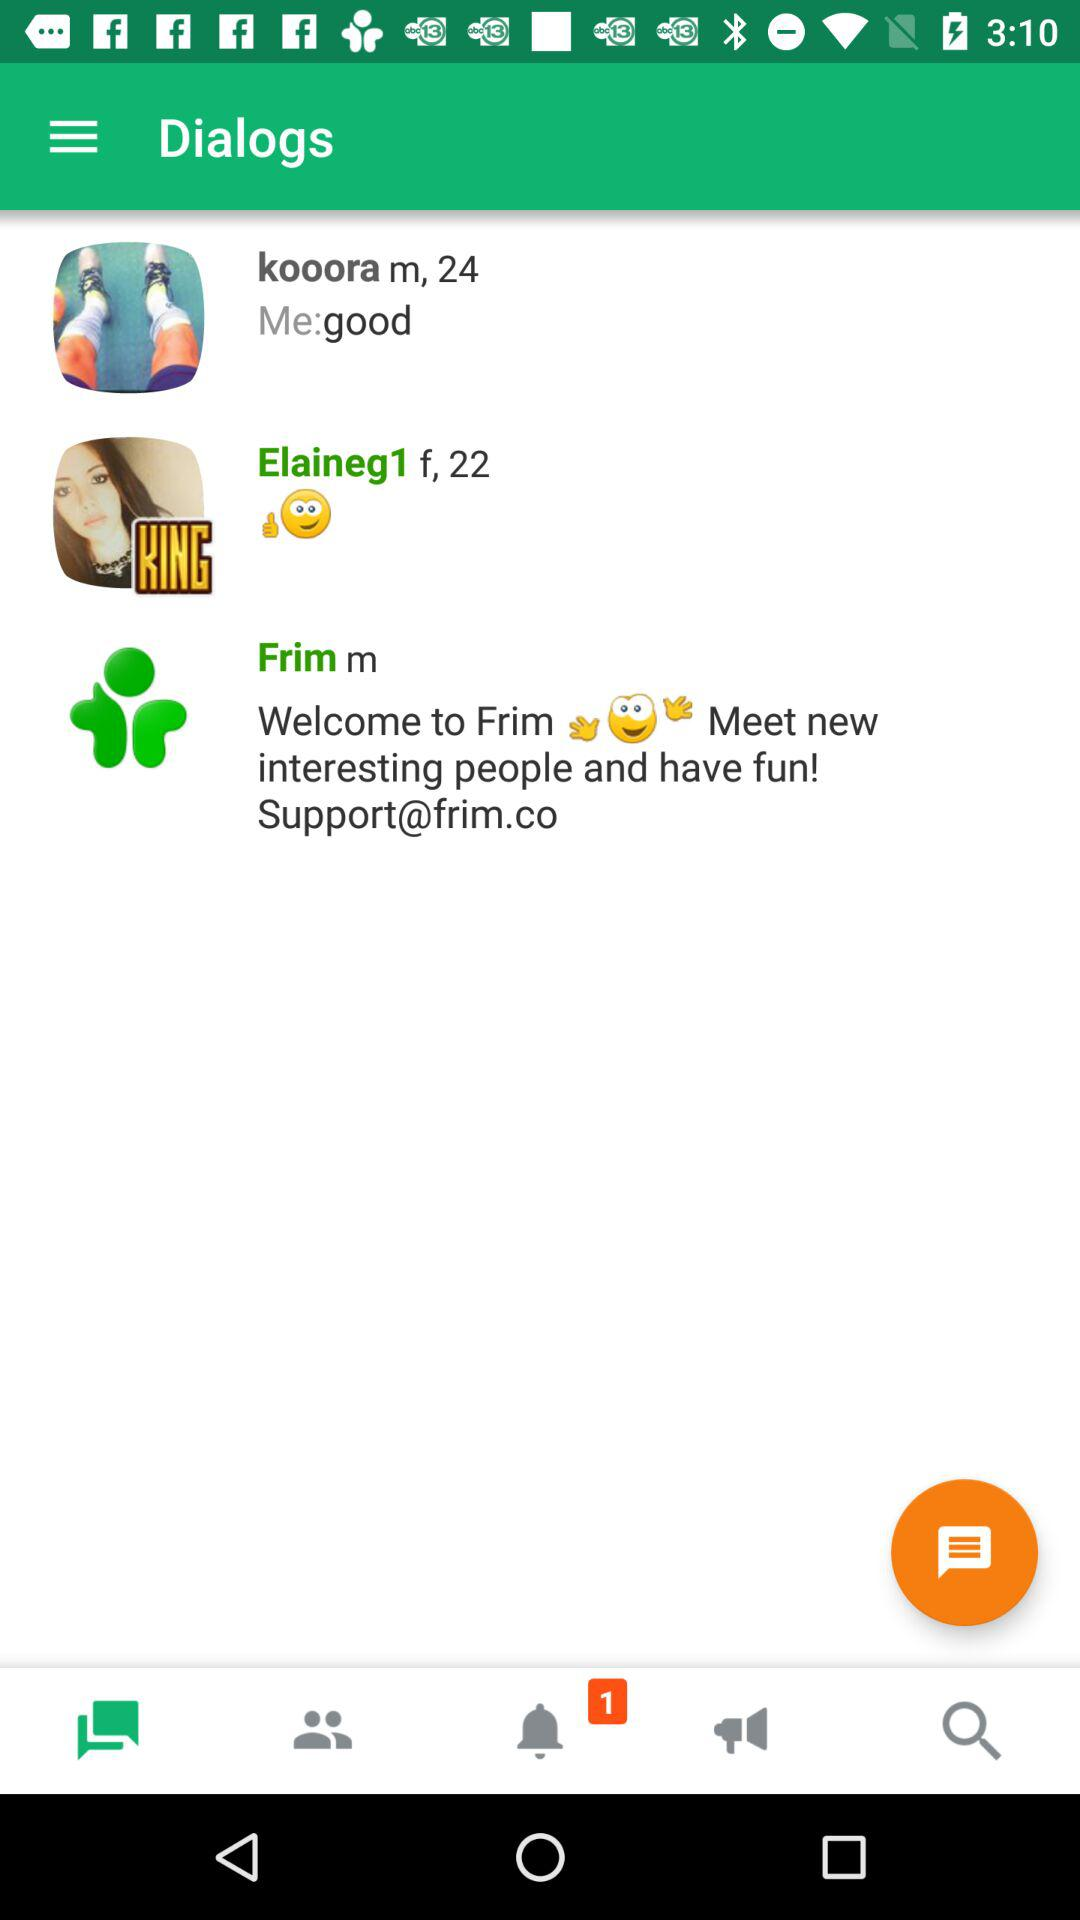What the the support website?
When the provided information is insufficient, respond with <no answer>. <no answer> 